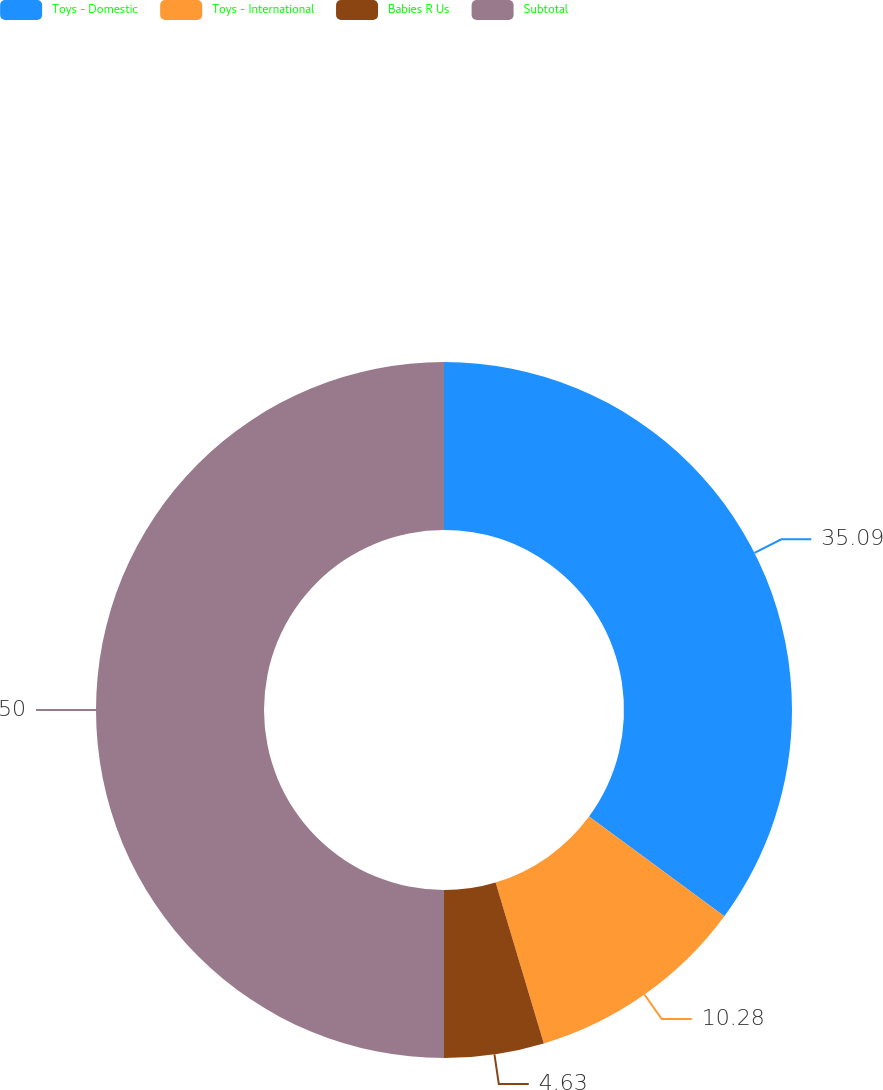Convert chart. <chart><loc_0><loc_0><loc_500><loc_500><pie_chart><fcel>Toys - Domestic<fcel>Toys - International<fcel>Babies R Us<fcel>Subtotal<nl><fcel>35.09%<fcel>10.28%<fcel>4.63%<fcel>50.0%<nl></chart> 